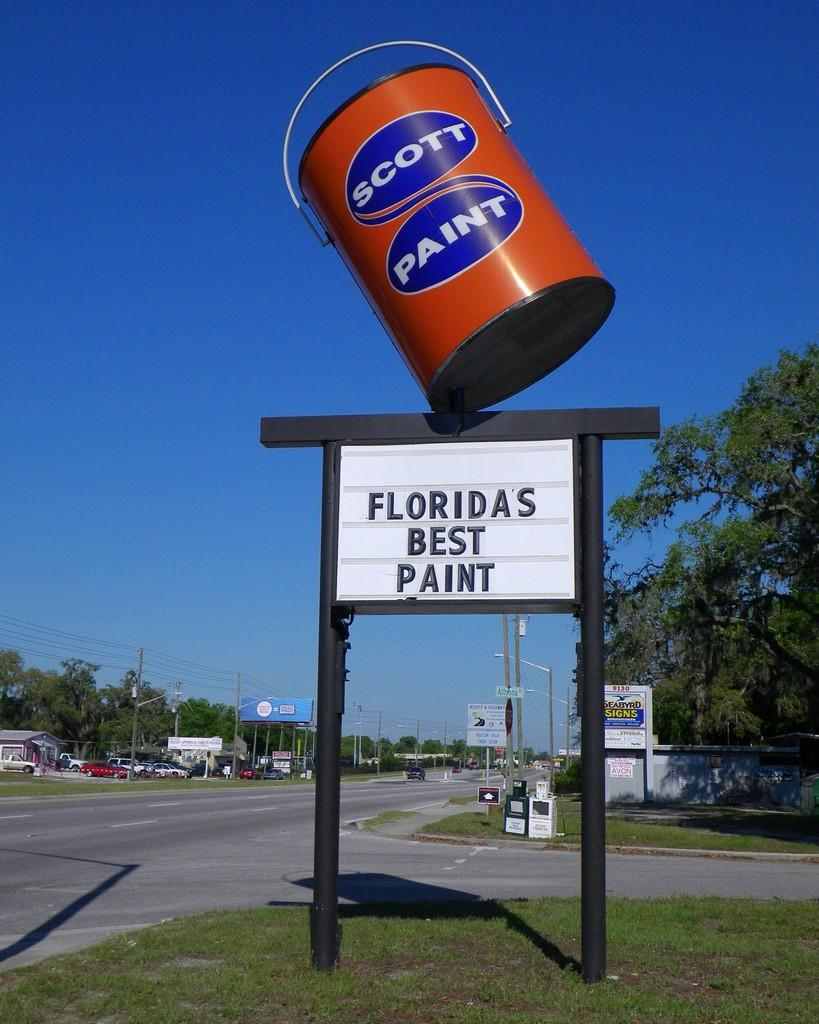What is on the name board in the image? There is a bucket on the name board in the image. What type of pathway can be seen in the image? There is a road visible in the image. What type of vegetation is present in the image? Grass is present in the image. What type of transportation is visible in the image? Vehicles are visible in the image. What type of natural feature is present in the image? Trees are present in the image. What type of structures are visible in the image? Poles are visible in the image. What type of decorative items are present in the image? Banners are present in the image. What type of utility infrastructure is visible in the image? Wires are visible in the image. What is visible in the background of the image? The sky is visible in the background of the image. Can you tell me how many hills are visible in the image? There are no hills visible in the image. What type of father is present in the image? There is no father present in the image. 